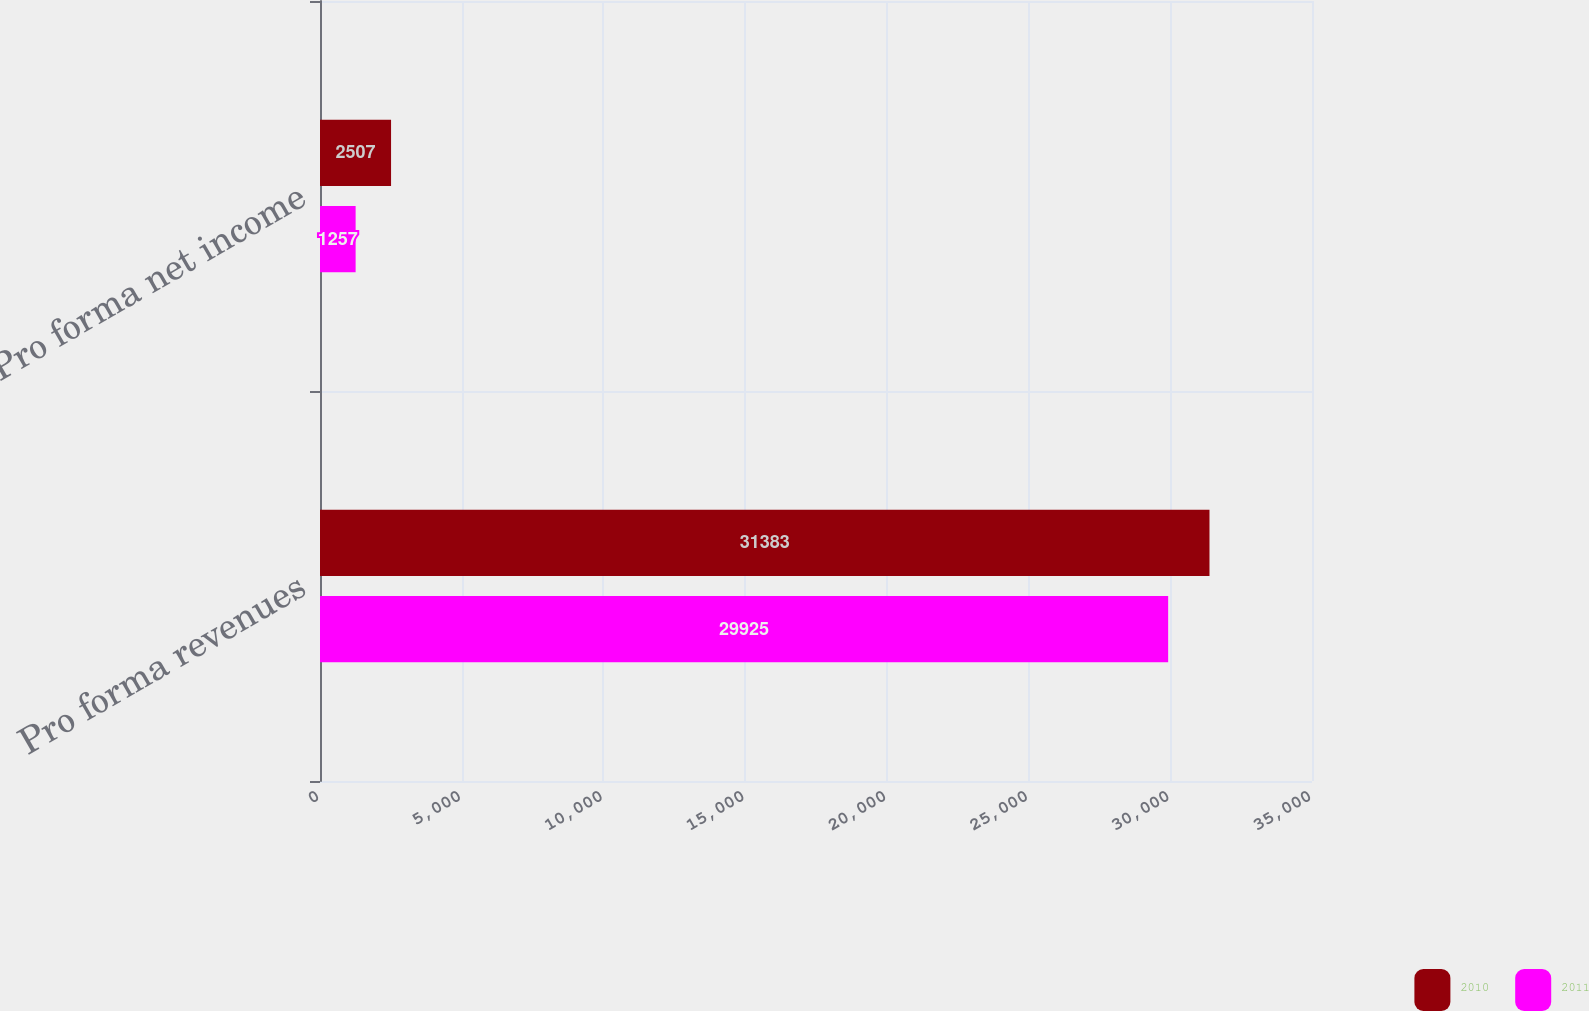<chart> <loc_0><loc_0><loc_500><loc_500><stacked_bar_chart><ecel><fcel>Pro forma revenues<fcel>Pro forma net income<nl><fcel>2010<fcel>31383<fcel>2507<nl><fcel>2011<fcel>29925<fcel>1257<nl></chart> 